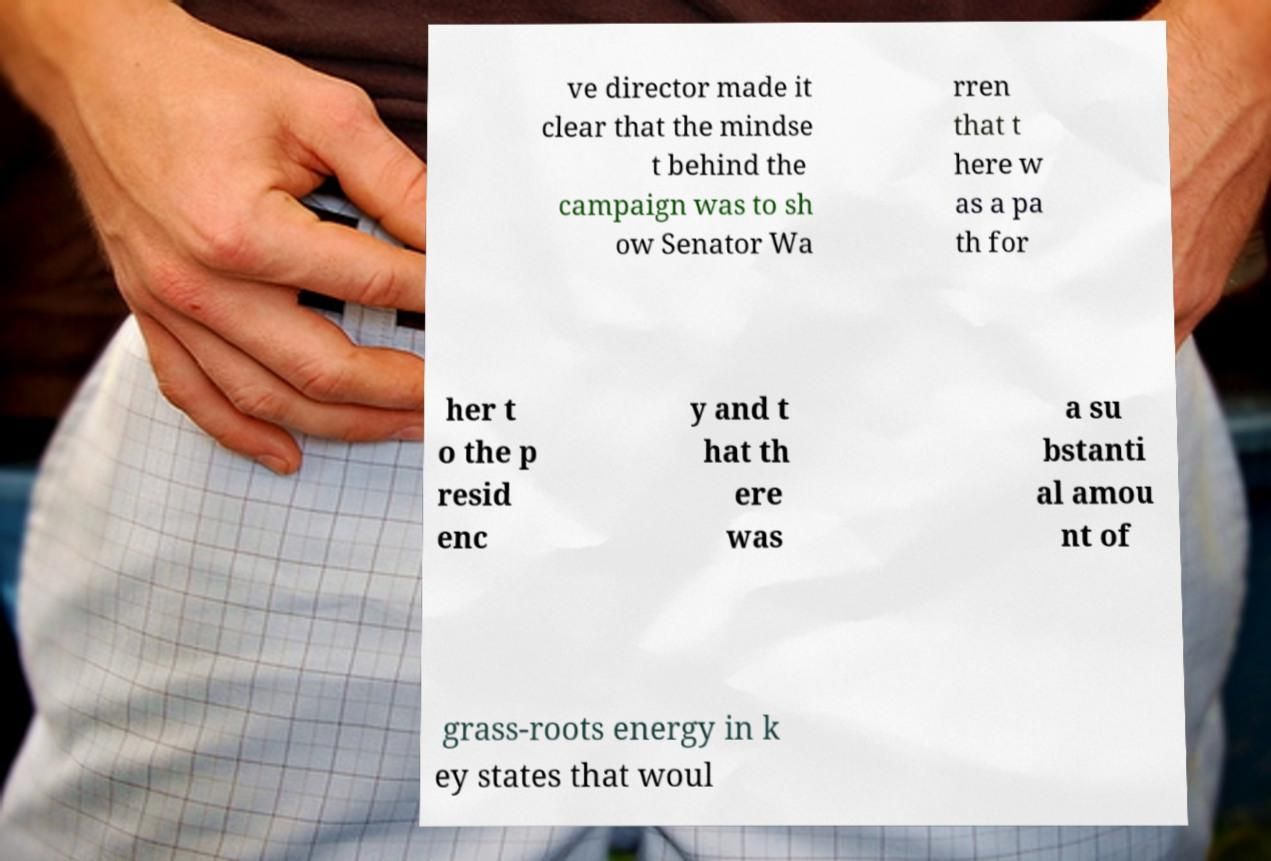For documentation purposes, I need the text within this image transcribed. Could you provide that? ve director made it clear that the mindse t behind the campaign was to sh ow Senator Wa rren that t here w as a pa th for her t o the p resid enc y and t hat th ere was a su bstanti al amou nt of grass-roots energy in k ey states that woul 